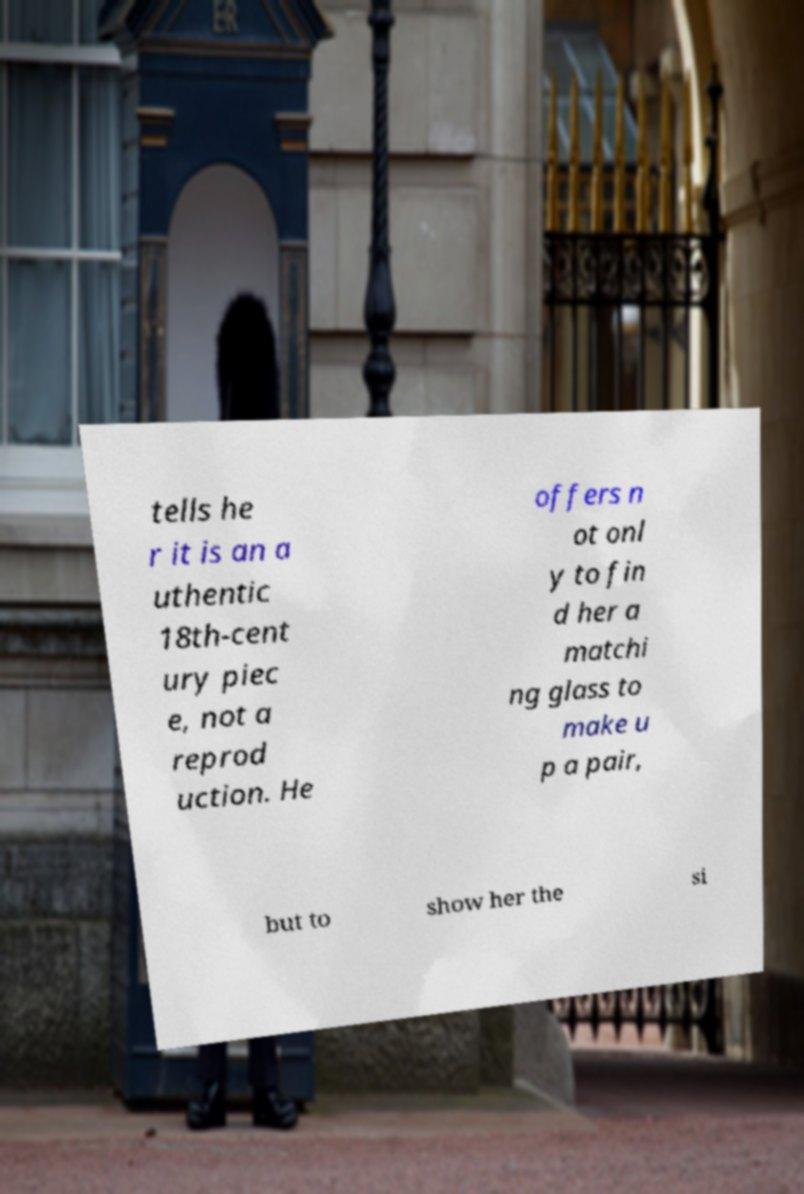There's text embedded in this image that I need extracted. Can you transcribe it verbatim? tells he r it is an a uthentic 18th-cent ury piec e, not a reprod uction. He offers n ot onl y to fin d her a matchi ng glass to make u p a pair, but to show her the si 